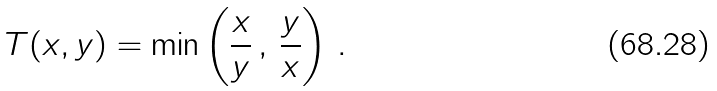Convert formula to latex. <formula><loc_0><loc_0><loc_500><loc_500>T ( x , y ) = \min \left ( \frac { x } { y } \, , \, \frac { y } { x } \right ) \, .</formula> 